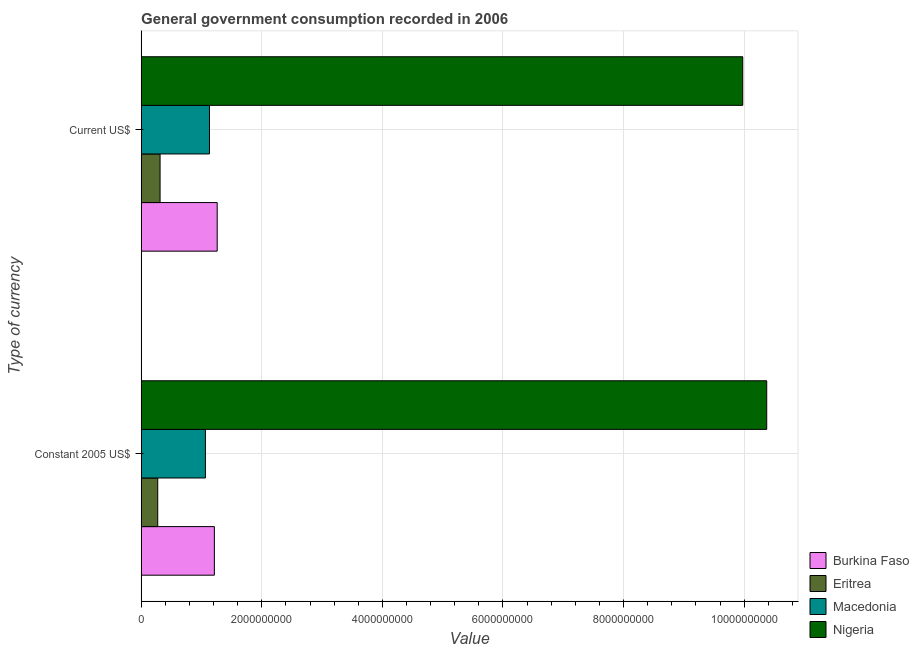Are the number of bars per tick equal to the number of legend labels?
Provide a short and direct response. Yes. How many bars are there on the 2nd tick from the top?
Make the answer very short. 4. What is the label of the 1st group of bars from the top?
Your answer should be very brief. Current US$. What is the value consumed in constant 2005 us$ in Burkina Faso?
Provide a short and direct response. 1.21e+09. Across all countries, what is the maximum value consumed in constant 2005 us$?
Make the answer very short. 1.04e+1. Across all countries, what is the minimum value consumed in current us$?
Ensure brevity in your answer.  3.14e+08. In which country was the value consumed in current us$ maximum?
Give a very brief answer. Nigeria. In which country was the value consumed in current us$ minimum?
Your response must be concise. Eritrea. What is the total value consumed in current us$ in the graph?
Offer a very short reply. 1.27e+1. What is the difference between the value consumed in current us$ in Burkina Faso and that in Eritrea?
Ensure brevity in your answer.  9.47e+08. What is the difference between the value consumed in current us$ in Macedonia and the value consumed in constant 2005 us$ in Eritrea?
Provide a succinct answer. 8.58e+08. What is the average value consumed in current us$ per country?
Your response must be concise. 3.17e+09. What is the difference between the value consumed in constant 2005 us$ and value consumed in current us$ in Burkina Faso?
Make the answer very short. -4.67e+07. In how many countries, is the value consumed in constant 2005 us$ greater than 9200000000 ?
Keep it short and to the point. 1. What is the ratio of the value consumed in current us$ in Nigeria to that in Eritrea?
Your answer should be compact. 31.78. What does the 2nd bar from the top in Current US$ represents?
Your answer should be compact. Macedonia. What does the 3rd bar from the bottom in Constant 2005 US$ represents?
Your response must be concise. Macedonia. Are the values on the major ticks of X-axis written in scientific E-notation?
Your response must be concise. No. Does the graph contain any zero values?
Make the answer very short. No. What is the title of the graph?
Your response must be concise. General government consumption recorded in 2006. Does "Philippines" appear as one of the legend labels in the graph?
Provide a succinct answer. No. What is the label or title of the X-axis?
Your answer should be very brief. Value. What is the label or title of the Y-axis?
Your answer should be compact. Type of currency. What is the Value of Burkina Faso in Constant 2005 US$?
Keep it short and to the point. 1.21e+09. What is the Value in Eritrea in Constant 2005 US$?
Your answer should be very brief. 2.75e+08. What is the Value of Macedonia in Constant 2005 US$?
Your answer should be compact. 1.07e+09. What is the Value in Nigeria in Constant 2005 US$?
Offer a terse response. 1.04e+1. What is the Value in Burkina Faso in Current US$?
Provide a succinct answer. 1.26e+09. What is the Value of Eritrea in Current US$?
Offer a very short reply. 3.14e+08. What is the Value in Macedonia in Current US$?
Provide a succinct answer. 1.13e+09. What is the Value of Nigeria in Current US$?
Make the answer very short. 9.98e+09. Across all Type of currency, what is the maximum Value of Burkina Faso?
Make the answer very short. 1.26e+09. Across all Type of currency, what is the maximum Value in Eritrea?
Your answer should be compact. 3.14e+08. Across all Type of currency, what is the maximum Value in Macedonia?
Provide a short and direct response. 1.13e+09. Across all Type of currency, what is the maximum Value of Nigeria?
Provide a succinct answer. 1.04e+1. Across all Type of currency, what is the minimum Value of Burkina Faso?
Provide a succinct answer. 1.21e+09. Across all Type of currency, what is the minimum Value in Eritrea?
Offer a very short reply. 2.75e+08. Across all Type of currency, what is the minimum Value in Macedonia?
Provide a succinct answer. 1.07e+09. Across all Type of currency, what is the minimum Value in Nigeria?
Give a very brief answer. 9.98e+09. What is the total Value in Burkina Faso in the graph?
Ensure brevity in your answer.  2.47e+09. What is the total Value in Eritrea in the graph?
Your answer should be very brief. 5.89e+08. What is the total Value of Macedonia in the graph?
Ensure brevity in your answer.  2.20e+09. What is the total Value in Nigeria in the graph?
Offer a very short reply. 2.03e+1. What is the difference between the Value of Burkina Faso in Constant 2005 US$ and that in Current US$?
Offer a terse response. -4.67e+07. What is the difference between the Value in Eritrea in Constant 2005 US$ and that in Current US$?
Offer a very short reply. -3.88e+07. What is the difference between the Value in Macedonia in Constant 2005 US$ and that in Current US$?
Provide a short and direct response. -6.71e+07. What is the difference between the Value in Nigeria in Constant 2005 US$ and that in Current US$?
Provide a short and direct response. 3.97e+08. What is the difference between the Value in Burkina Faso in Constant 2005 US$ and the Value in Eritrea in Current US$?
Provide a short and direct response. 9.00e+08. What is the difference between the Value of Burkina Faso in Constant 2005 US$ and the Value of Macedonia in Current US$?
Your answer should be compact. 8.13e+07. What is the difference between the Value of Burkina Faso in Constant 2005 US$ and the Value of Nigeria in Current US$?
Provide a succinct answer. -8.76e+09. What is the difference between the Value in Eritrea in Constant 2005 US$ and the Value in Macedonia in Current US$?
Give a very brief answer. -8.58e+08. What is the difference between the Value in Eritrea in Constant 2005 US$ and the Value in Nigeria in Current US$?
Give a very brief answer. -9.70e+09. What is the difference between the Value in Macedonia in Constant 2005 US$ and the Value in Nigeria in Current US$?
Provide a succinct answer. -8.91e+09. What is the average Value in Burkina Faso per Type of currency?
Provide a succinct answer. 1.24e+09. What is the average Value in Eritrea per Type of currency?
Provide a succinct answer. 2.95e+08. What is the average Value in Macedonia per Type of currency?
Keep it short and to the point. 1.10e+09. What is the average Value of Nigeria per Type of currency?
Keep it short and to the point. 1.02e+1. What is the difference between the Value of Burkina Faso and Value of Eritrea in Constant 2005 US$?
Offer a terse response. 9.39e+08. What is the difference between the Value of Burkina Faso and Value of Macedonia in Constant 2005 US$?
Make the answer very short. 1.48e+08. What is the difference between the Value of Burkina Faso and Value of Nigeria in Constant 2005 US$?
Give a very brief answer. -9.16e+09. What is the difference between the Value of Eritrea and Value of Macedonia in Constant 2005 US$?
Keep it short and to the point. -7.91e+08. What is the difference between the Value in Eritrea and Value in Nigeria in Constant 2005 US$?
Your answer should be very brief. -1.01e+1. What is the difference between the Value of Macedonia and Value of Nigeria in Constant 2005 US$?
Make the answer very short. -9.31e+09. What is the difference between the Value of Burkina Faso and Value of Eritrea in Current US$?
Provide a short and direct response. 9.47e+08. What is the difference between the Value in Burkina Faso and Value in Macedonia in Current US$?
Your answer should be compact. 1.28e+08. What is the difference between the Value of Burkina Faso and Value of Nigeria in Current US$?
Keep it short and to the point. -8.71e+09. What is the difference between the Value in Eritrea and Value in Macedonia in Current US$?
Your answer should be compact. -8.19e+08. What is the difference between the Value of Eritrea and Value of Nigeria in Current US$?
Provide a short and direct response. -9.66e+09. What is the difference between the Value in Macedonia and Value in Nigeria in Current US$?
Give a very brief answer. -8.84e+09. What is the ratio of the Value of Burkina Faso in Constant 2005 US$ to that in Current US$?
Give a very brief answer. 0.96. What is the ratio of the Value of Eritrea in Constant 2005 US$ to that in Current US$?
Provide a short and direct response. 0.88. What is the ratio of the Value of Macedonia in Constant 2005 US$ to that in Current US$?
Ensure brevity in your answer.  0.94. What is the ratio of the Value of Nigeria in Constant 2005 US$ to that in Current US$?
Offer a terse response. 1.04. What is the difference between the highest and the second highest Value in Burkina Faso?
Your response must be concise. 4.67e+07. What is the difference between the highest and the second highest Value in Eritrea?
Keep it short and to the point. 3.88e+07. What is the difference between the highest and the second highest Value of Macedonia?
Make the answer very short. 6.71e+07. What is the difference between the highest and the second highest Value of Nigeria?
Your answer should be compact. 3.97e+08. What is the difference between the highest and the lowest Value of Burkina Faso?
Your answer should be very brief. 4.67e+07. What is the difference between the highest and the lowest Value of Eritrea?
Provide a short and direct response. 3.88e+07. What is the difference between the highest and the lowest Value in Macedonia?
Provide a short and direct response. 6.71e+07. What is the difference between the highest and the lowest Value in Nigeria?
Provide a succinct answer. 3.97e+08. 